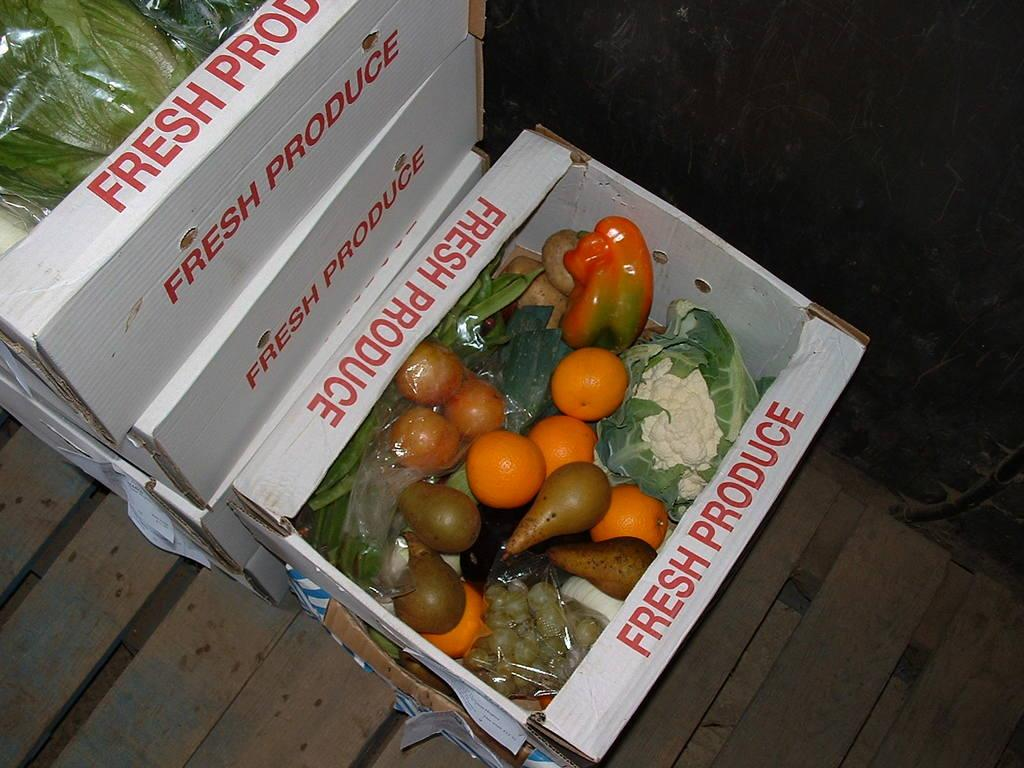What objects are present in the image? There are boxes in the image. What are the boxes containing? The boxes contain vegetables. Can you describe the object at the bottom of the image? There is a wooden block at the bottom of the image. How many sisters are depicted working on the vegetable farm in the image? There are no people, let alone sisters, depicted in the image; it only features boxes containing vegetables and a wooden block. What type of plough is being used to till the soil in the image? There is no plough present in the image; it only features boxes containing vegetables and a wooden block. 